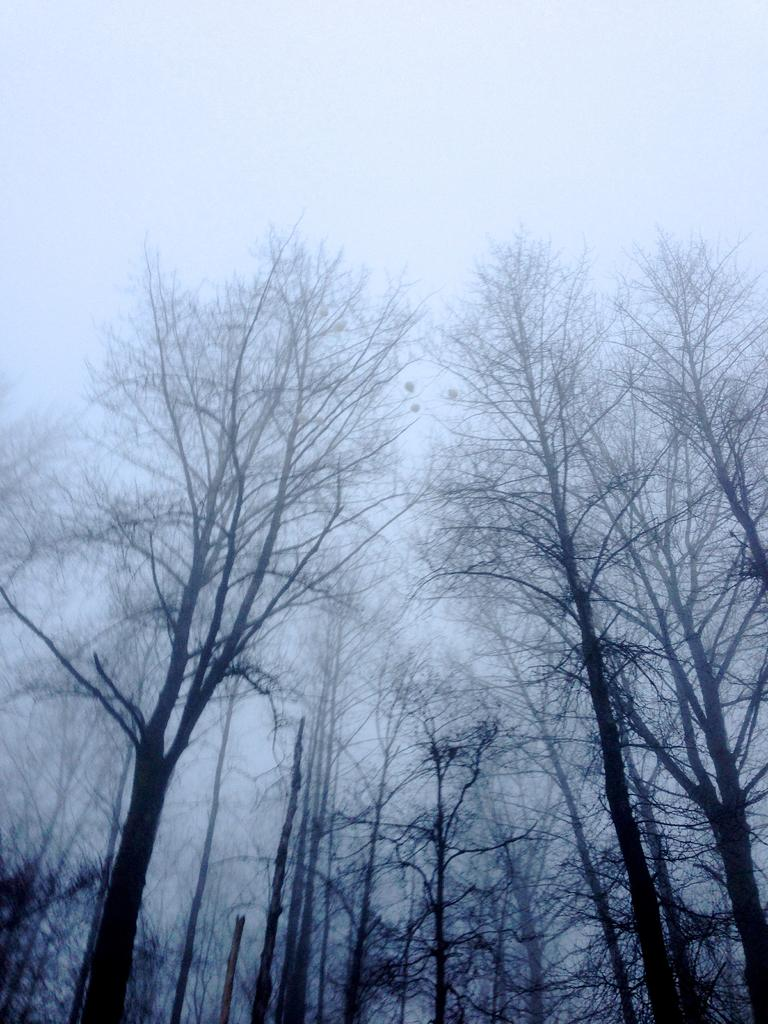What is the main feature in the foreground of the image? There are many trees in the foreground of the image. What color is the background of the image? The background of the image is white. What word is written on the shirt of the person in the image? There is no person or shirt present in the image; it features many trees in the foreground and a white background. How many sticks are visible in the image? There are no sticks visible in the image; it features many trees in the foreground and a white background. 